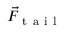Convert formula to latex. <formula><loc_0><loc_0><loc_500><loc_500>\vec { F } _ { t a i l }</formula> 